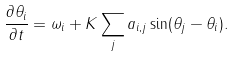Convert formula to latex. <formula><loc_0><loc_0><loc_500><loc_500>\frac { \partial \theta _ { i } } { \partial t } = \omega _ { i } + K \sum _ { j } a _ { i , j } \sin ( \theta _ { j } - \theta _ { i } ) .</formula> 